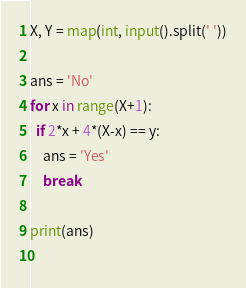Convert code to text. <code><loc_0><loc_0><loc_500><loc_500><_Python_>X, Y = map(int, input().split(' '))

ans = 'No'
for x in range(X+1):
  if 2*x + 4*(X-x) == y:
    ans = 'Yes'
    break
    
print(ans)
  </code> 